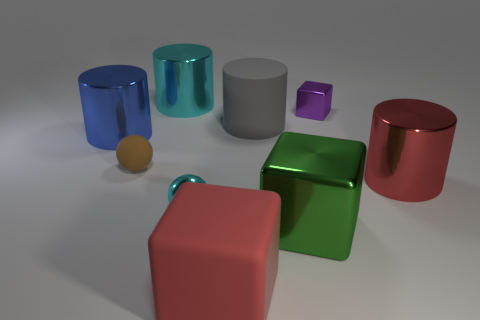There is a large shiny cylinder to the right of the cyan thing behind the large matte object right of the large red matte block; what is its color?
Your answer should be very brief. Red. How many things are large blue metal cylinders or small rubber balls?
Provide a short and direct response. 2. What number of gray matte objects are the same shape as the big red metallic object?
Your response must be concise. 1. Do the brown object and the cylinder in front of the small rubber thing have the same material?
Provide a succinct answer. No. There is a cyan cylinder that is the same material as the big green thing; what size is it?
Your answer should be very brief. Large. There is a cyan thing in front of the gray object; what is its size?
Offer a very short reply. Small. How many red rubber things have the same size as the blue thing?
Make the answer very short. 1. There is a metallic object that is the same color as the metal sphere; what is its size?
Offer a very short reply. Large. Is there a metallic cylinder of the same color as the small matte sphere?
Offer a terse response. No. There is a shiny object that is the same size as the cyan metallic sphere; what is its color?
Make the answer very short. Purple. 